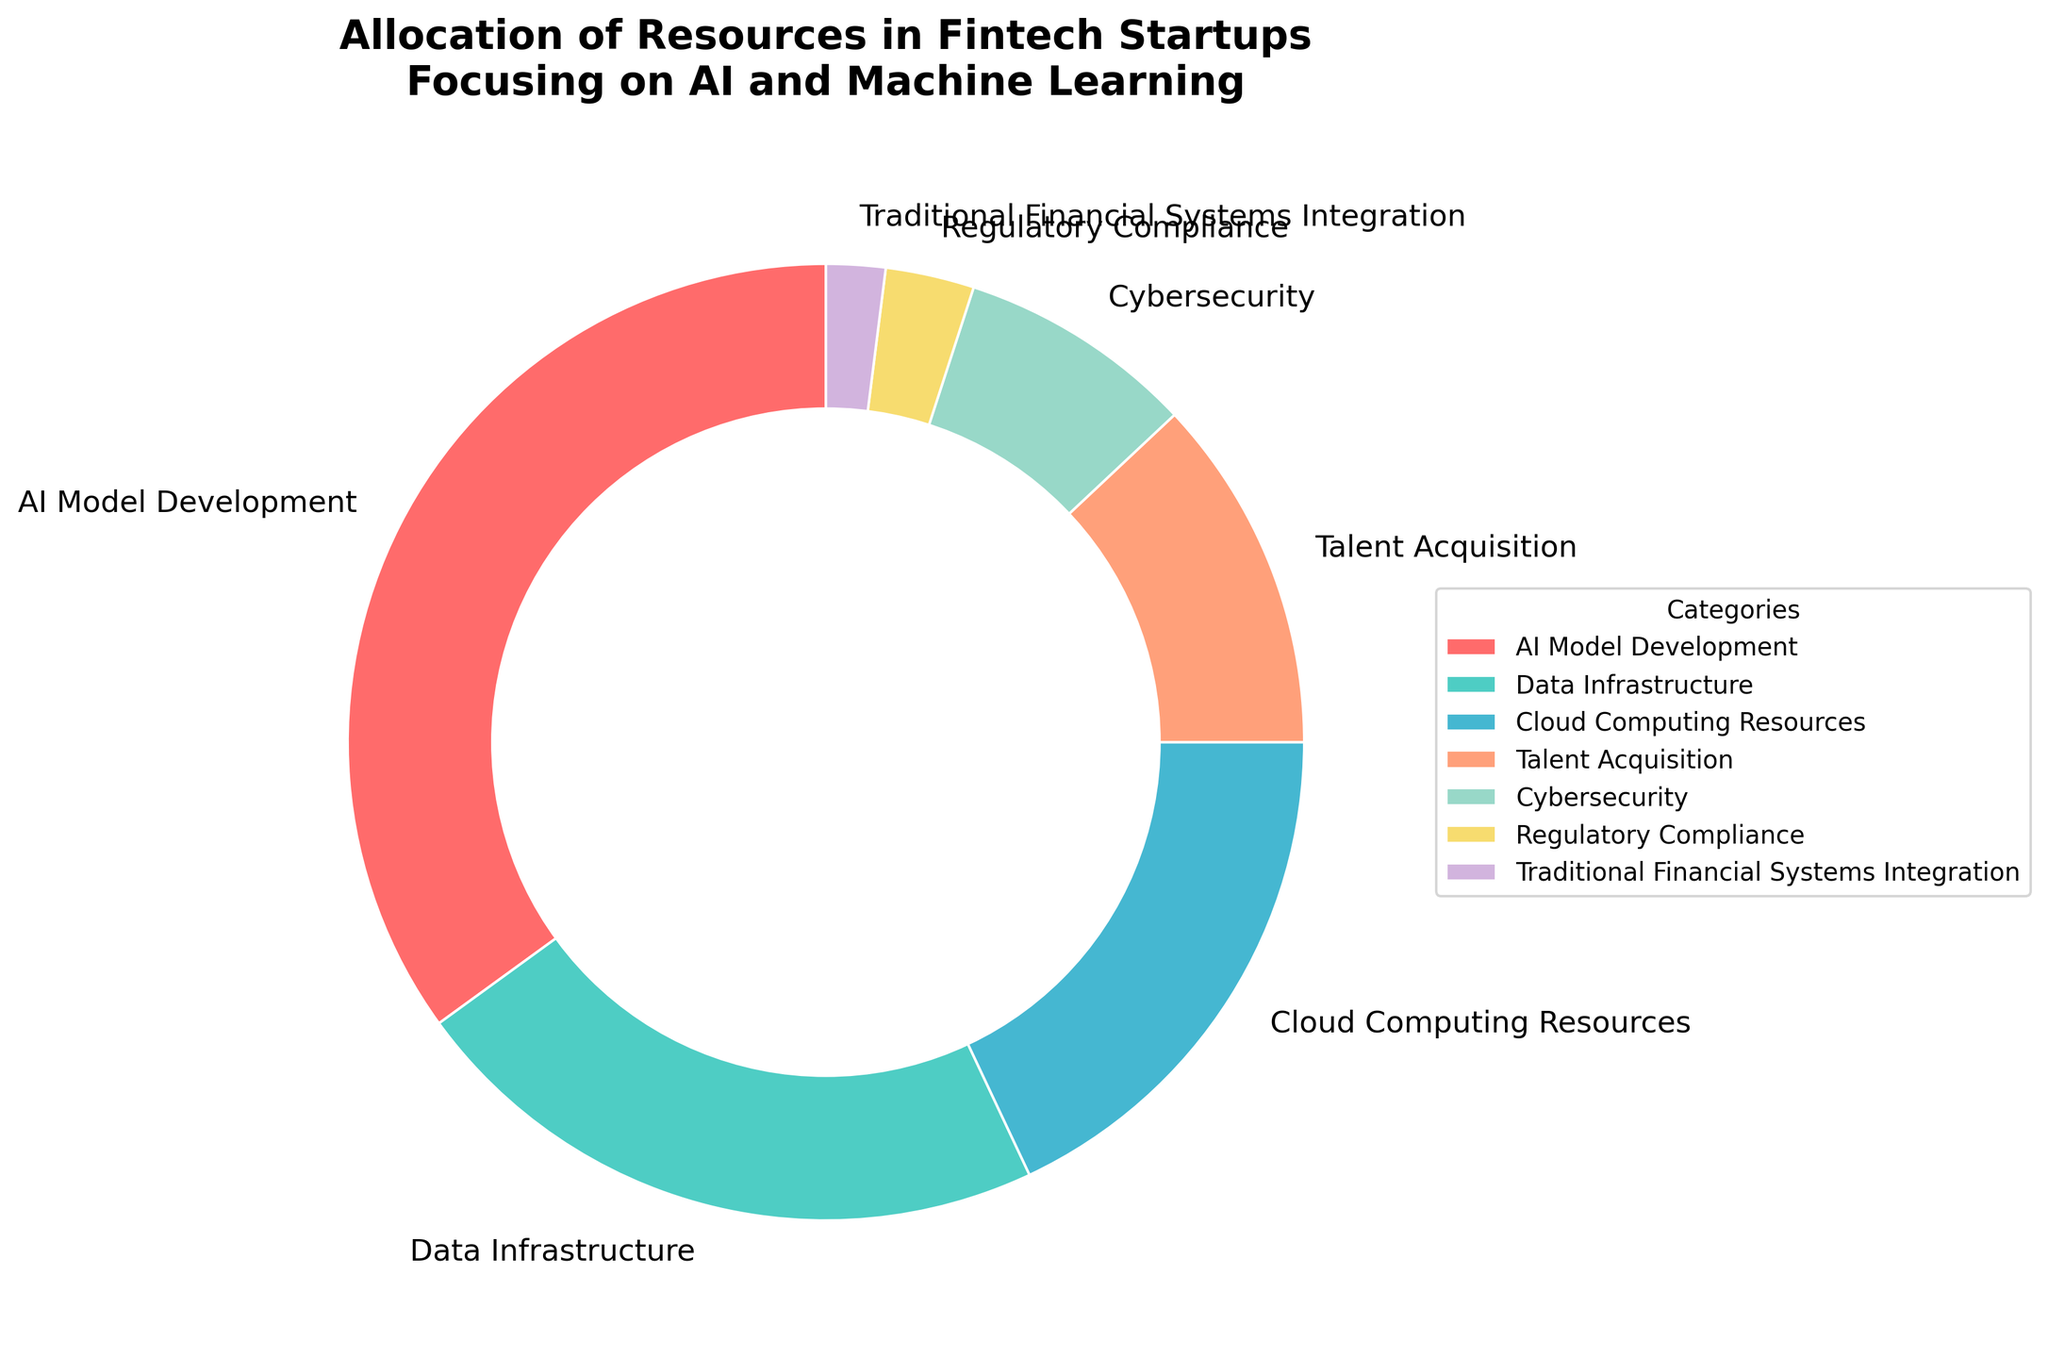What's the sum of the percentages allocated to AI Model Development and Talent Acquisition? First, identify the percentages for AI Model Development (35%) and Talent Acquisition (12%) from the pie chart. Next, add these two percentages: 35 + 12 = 47. So, the sum is 47%.
Answer: 47% Which category has a higher percentage allocation: Data Infrastructure or Cloud Computing Resources? Identify the percentages for Data Infrastructure (22%) and Cloud Computing Resources (18%) from the pie chart. Compare these two values: 22 is greater than 18. Thus, Data Infrastructure has a higher percentage allocation than Cloud Computing Resources.
Answer: Data Infrastructure What is the total percentage allocated to categories with less than 10% allocation each? Identify the categories with less than 10% allocation: Cybersecurity (8%), Regulatory Compliance (3%), and Traditional Financial Systems Integration (2%). Add these percentages: 8 + 3 + 2 = 13. So, the total percentage is 13%.
Answer: 13% What is the difference in percentage allocation between AI Model Development and Cybersecurity? Identify the percentages for AI Model Development (35%) and Cybersecurity (8%) from the pie chart. Subtract the smaller percentage from the larger one: 35 - 8 = 27. Thus, the difference is 27%.
Answer: 27% Which category is represented by the green color in the pie chart? Observe the pie chart and match the green color segment to its corresponding category label. The green segment corresponds to Data Infrastructure.
Answer: Data Infrastructure Rank the top three categories by percentage allocation. Identify the percentages of all categories from the pie chart. The top three categories by percentage allocation are: AI Model Development (35%), Data Infrastructure (22%), and Cloud Computing Resources (18%).
Answer: AI Model Development, Data Infrastructure, Cloud Computing Resources Which category has the smallest allocation, and what is its percentage? Identify the category with the smallest percentage from the pie chart. Traditional Financial Systems Integration has the smallest allocation with 2%.
Answer: Traditional Financial Systems Integration, 2% What is the combined percentage allocation for Cloud Computing Resources and Cybersecurity? Identify the percentages for Cloud Computing Resources (18%) and Cybersecurity (8%) from the pie chart. Add these percentages: 18 + 8 = 26. Hence, the combined percentage is 26%.
Answer: 26% If the total budget is $1,000,000, how much is allocated to Talent Acquisition? Identify the percentage allocation for Talent Acquisition, which is 12%. Calculate the amount by using the percentage: (12/100) * $1,000,000 = $120,000. So, $120,000 is allocated to Talent Acquisition.
Answer: $120,000 